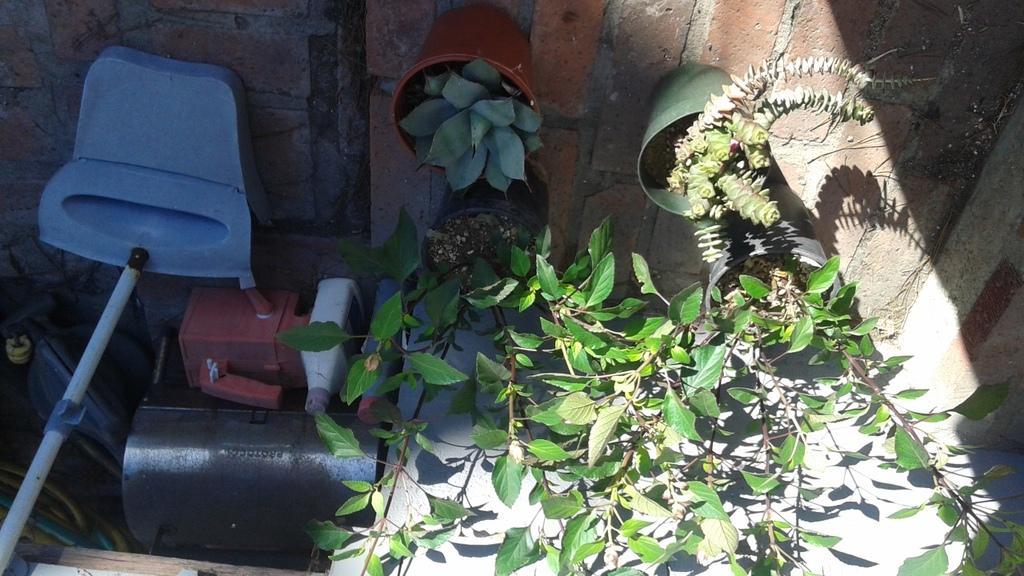Can you describe this image briefly? In this image I see the plants in the pots and I see bottles over here and I see a blue color thing over here and I see the stick and I see the ground and I see the wall over here. 